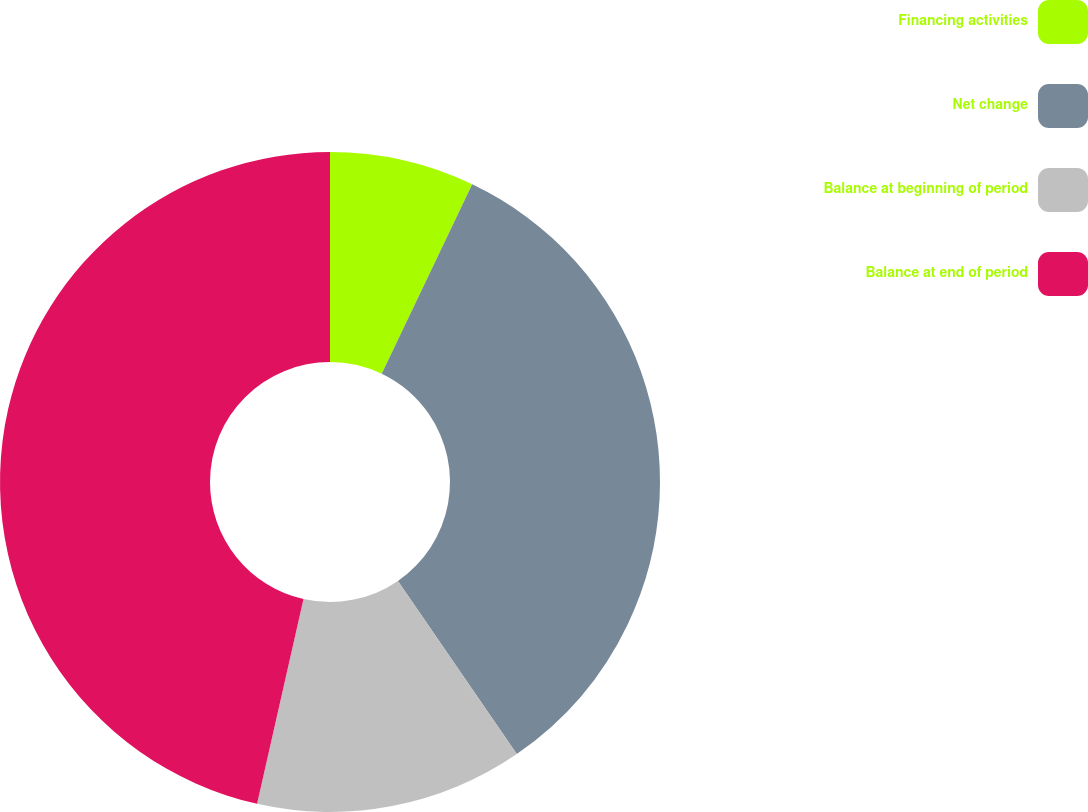Convert chart. <chart><loc_0><loc_0><loc_500><loc_500><pie_chart><fcel>Financing activities<fcel>Net change<fcel>Balance at beginning of period<fcel>Balance at end of period<nl><fcel>7.09%<fcel>33.33%<fcel>13.12%<fcel>46.45%<nl></chart> 